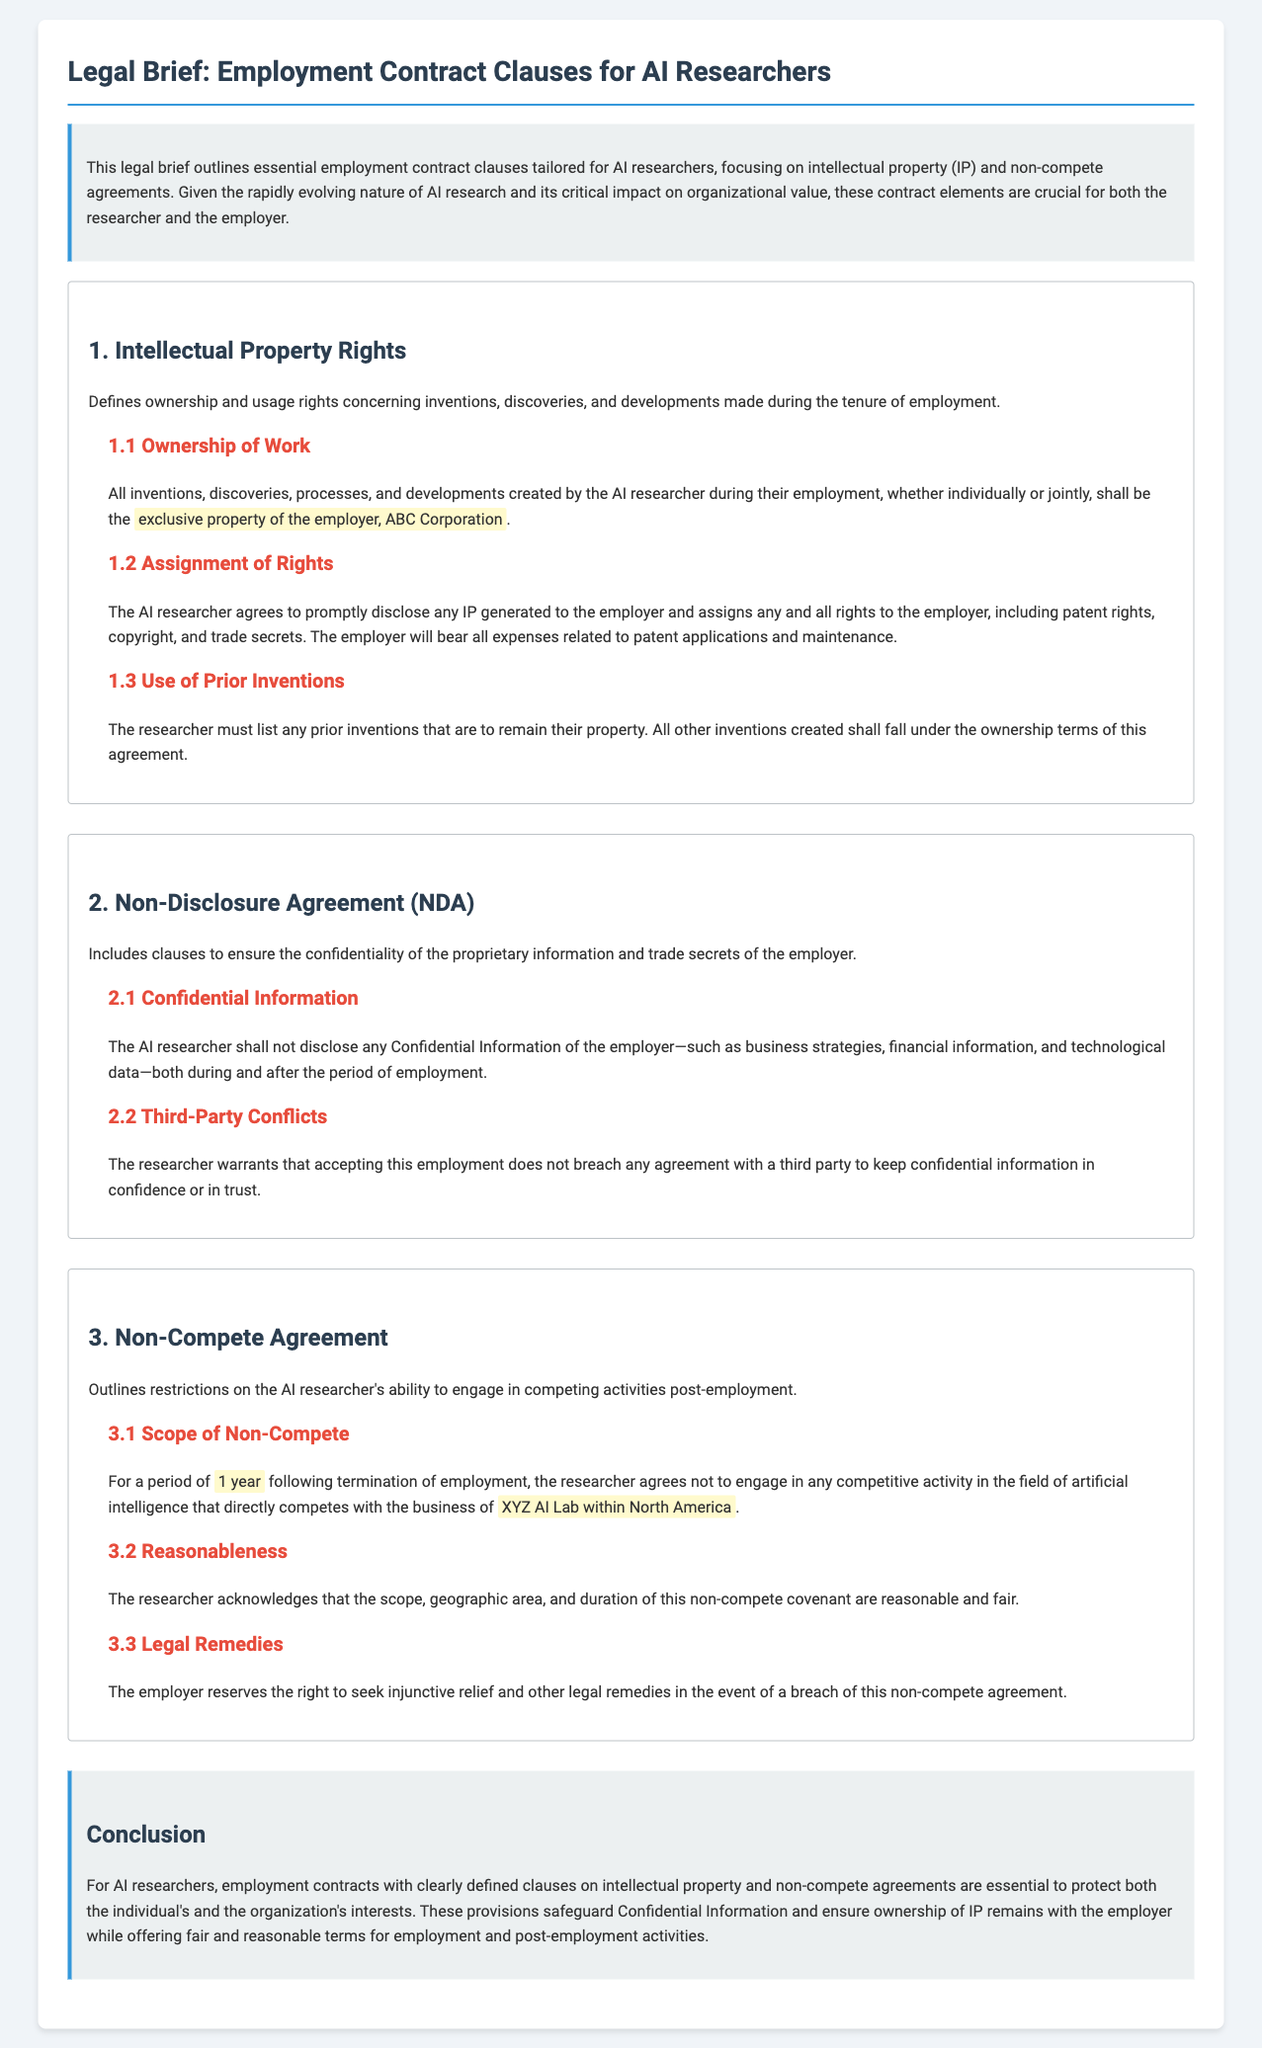What is the exclusive property of the employer? The legal document states that all inventions, discoveries, processes, and developments created by the AI researcher during their employment shall be the exclusive property of the employer.
Answer: exclusive property of the employer What is the duration of the non-compete agreement? The document specifies a period of one year following the termination of employment during which the researcher agrees not to engage in competing activities.
Answer: 1 year Who is the employer mentioned in the document? The brief identifies ABC Corporation as the employer in relation to intellectual property clauses.
Answer: ABC Corporation What type of agreement ensures confidentiality for proprietary information? The document refers to a Non-Disclosure Agreement (NDA) that includes clauses pertinent to the confidentiality of the employer's proprietary information.
Answer: Non-Disclosure Agreement (NDA) What does the researcher agree to disclose under the intellectual property rights clause? The AI researcher agrees to promptly disclose any IP generated to the employer, which includes their inventions and discoveries during employment.
Answer: any IP generated What is the employer's right if the non-compete agreement is breached? The document states that the employer reserves the right to seek injunctive relief and other legal remedies in the event of a breach of the non-compete agreement.
Answer: injunctive relief What must the researcher list to maintain ownership of prior inventions? The brief mentions that the researcher must list any prior inventions that are to remain their property according to the intellectual property rights clause.
Answer: prior inventions What clause covers third-party conflicts regarding confidential information? The document includes a subsection on Third-Party Conflicts under the Non-Disclosure Agreement, which addresses the researcher's warranty concerning third-party confidentiality obligations.
Answer: Third-Party Conflicts What is the primary focus of this legal brief? The document explicitly states that the brief outlines essential employment contract clauses specifically tailored for AI researchers, focusing on intellectual property and non-compete agreements.
Answer: Employment contract clauses for AI researchers 